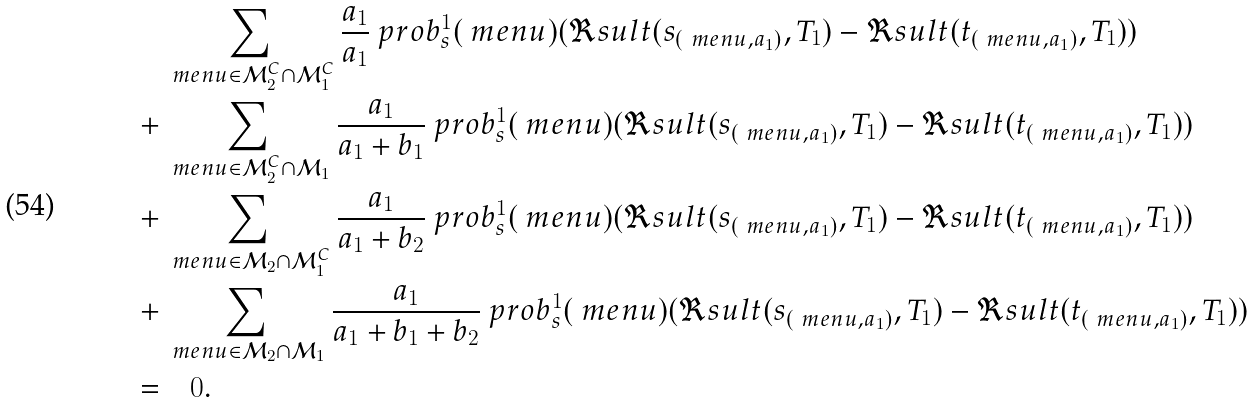<formula> <loc_0><loc_0><loc_500><loc_500>& \sum _ { \ m e n u \in \mathcal { M } _ { 2 } ^ { C } \cap \mathcal { M } _ { 1 } ^ { C } } \frac { a _ { 1 } } { a _ { 1 } } \ p r o b _ { s } ^ { 1 } ( \ m e n u ) ( \Re s u l t ( s _ { ( \ m e n u , a _ { 1 } ) } , T _ { 1 } ) - \Re s u l t ( t _ { ( \ m e n u , a _ { 1 } ) } , T _ { 1 } ) ) \\ + & \sum _ { \ m e n u \in \mathcal { M } _ { 2 } ^ { C } \cap \mathcal { M } _ { 1 } } \frac { a _ { 1 } } { a _ { 1 } + b _ { 1 } } \ p r o b _ { s } ^ { 1 } ( \ m e n u ) ( \Re s u l t ( s _ { ( \ m e n u , a _ { 1 } ) } , T _ { 1 } ) - \Re s u l t ( t _ { ( \ m e n u , a _ { 1 } ) } , T _ { 1 } ) ) \\ + & \sum _ { \ m e n u \in \mathcal { M } _ { 2 } \cap \mathcal { M } _ { 1 } ^ { C } } \frac { a _ { 1 } } { a _ { 1 } + b _ { 2 } } \ p r o b _ { s } ^ { 1 } ( \ m e n u ) ( \Re s u l t ( s _ { ( \ m e n u , a _ { 1 } ) } , T _ { 1 } ) - \Re s u l t ( t _ { ( \ m e n u , a _ { 1 } ) } , T _ { 1 } ) ) \\ + & \sum _ { \ m e n u \in \mathcal { M } _ { 2 } \cap \mathcal { M } _ { 1 } } \frac { a _ { 1 } } { a _ { 1 } + b _ { 1 } + b _ { 2 } } \ p r o b _ { s } ^ { 1 } ( \ m e n u ) ( \Re s u l t ( s _ { ( \ m e n u , a _ { 1 } ) } , T _ { 1 } ) - \Re s u l t ( t _ { ( \ m e n u , a _ { 1 } ) } , T _ { 1 } ) ) \\ = & \quad 0 .</formula> 